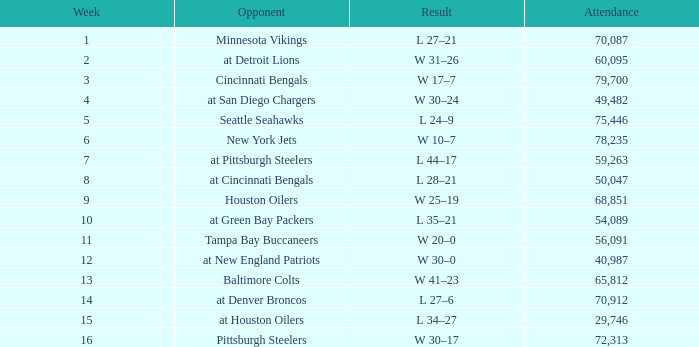What is the average attendance after week 16? None. 